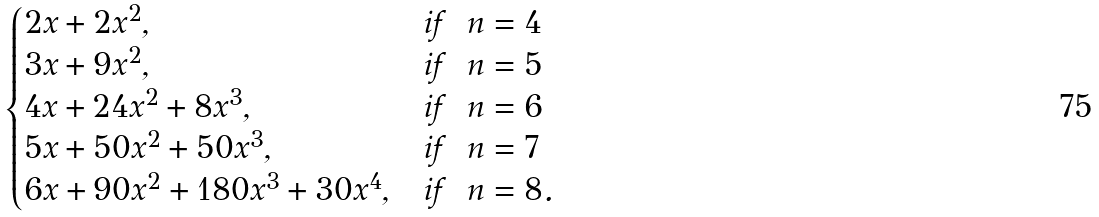<formula> <loc_0><loc_0><loc_500><loc_500>\begin{cases} 2 x + 2 x ^ { 2 } , & \text {if \ $n = 4$} \\ 3 x + 9 x ^ { 2 } , & \text {if \ $n = 5$} \\ 4 x + 2 4 x ^ { 2 } + 8 x ^ { 3 } , & \text {if \ $n = 6$} \\ 5 x + 5 0 x ^ { 2 } + 5 0 x ^ { 3 } , & \text {if \ $n = 7$} \\ 6 x + 9 0 x ^ { 2 } + 1 8 0 x ^ { 3 } + 3 0 x ^ { 4 } , & \text {if \ $n = 8$} . \end{cases}</formula> 